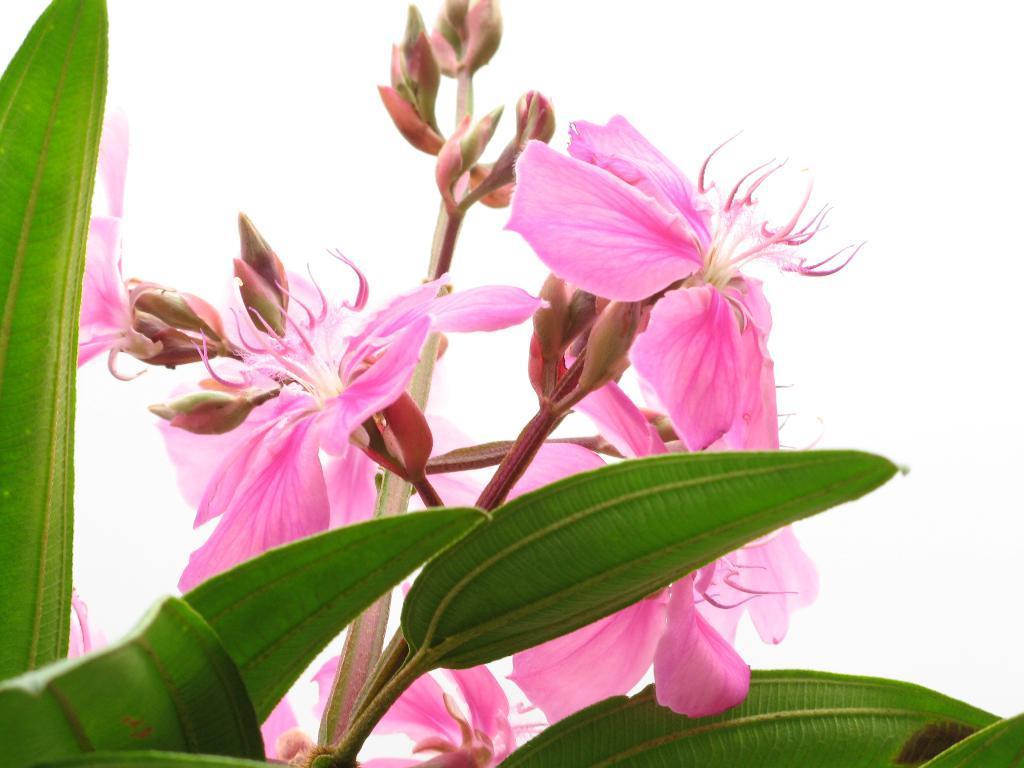Describe this image in one or two sentences. In the picture I can see flowers and leaves. 